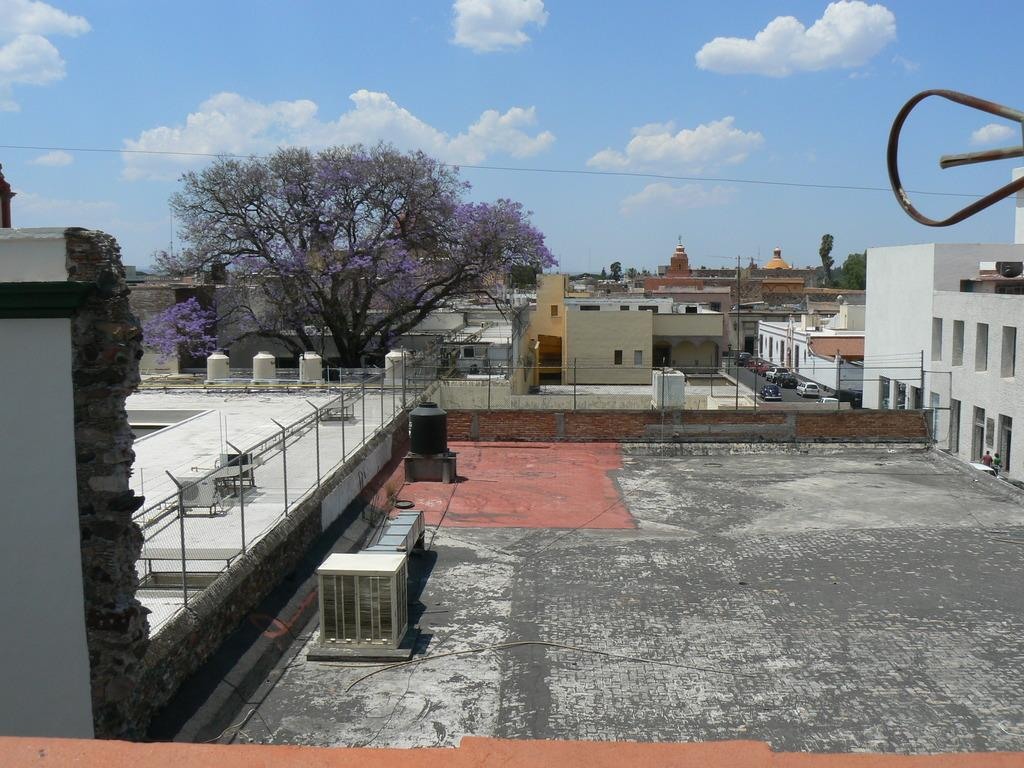What type of structures can be seen in the image? There are buildings in the image. What architectural feature is present in the image? There are railings in the image. How would you describe the weather in the image? The sky is cloudy in the image. What type of vegetation is visible in the image? There are trees in the image. Are there any living beings present in the image? Yes, there are people in the image. What mode of transportation can be seen in the image? There are vehicles in the image, and they are on the road. What type of stocking is hanging from the tree in the image? There is no stocking hanging from the tree in the image. What type of spade is being used by the person in the image? There is no person using a spade in the image. 